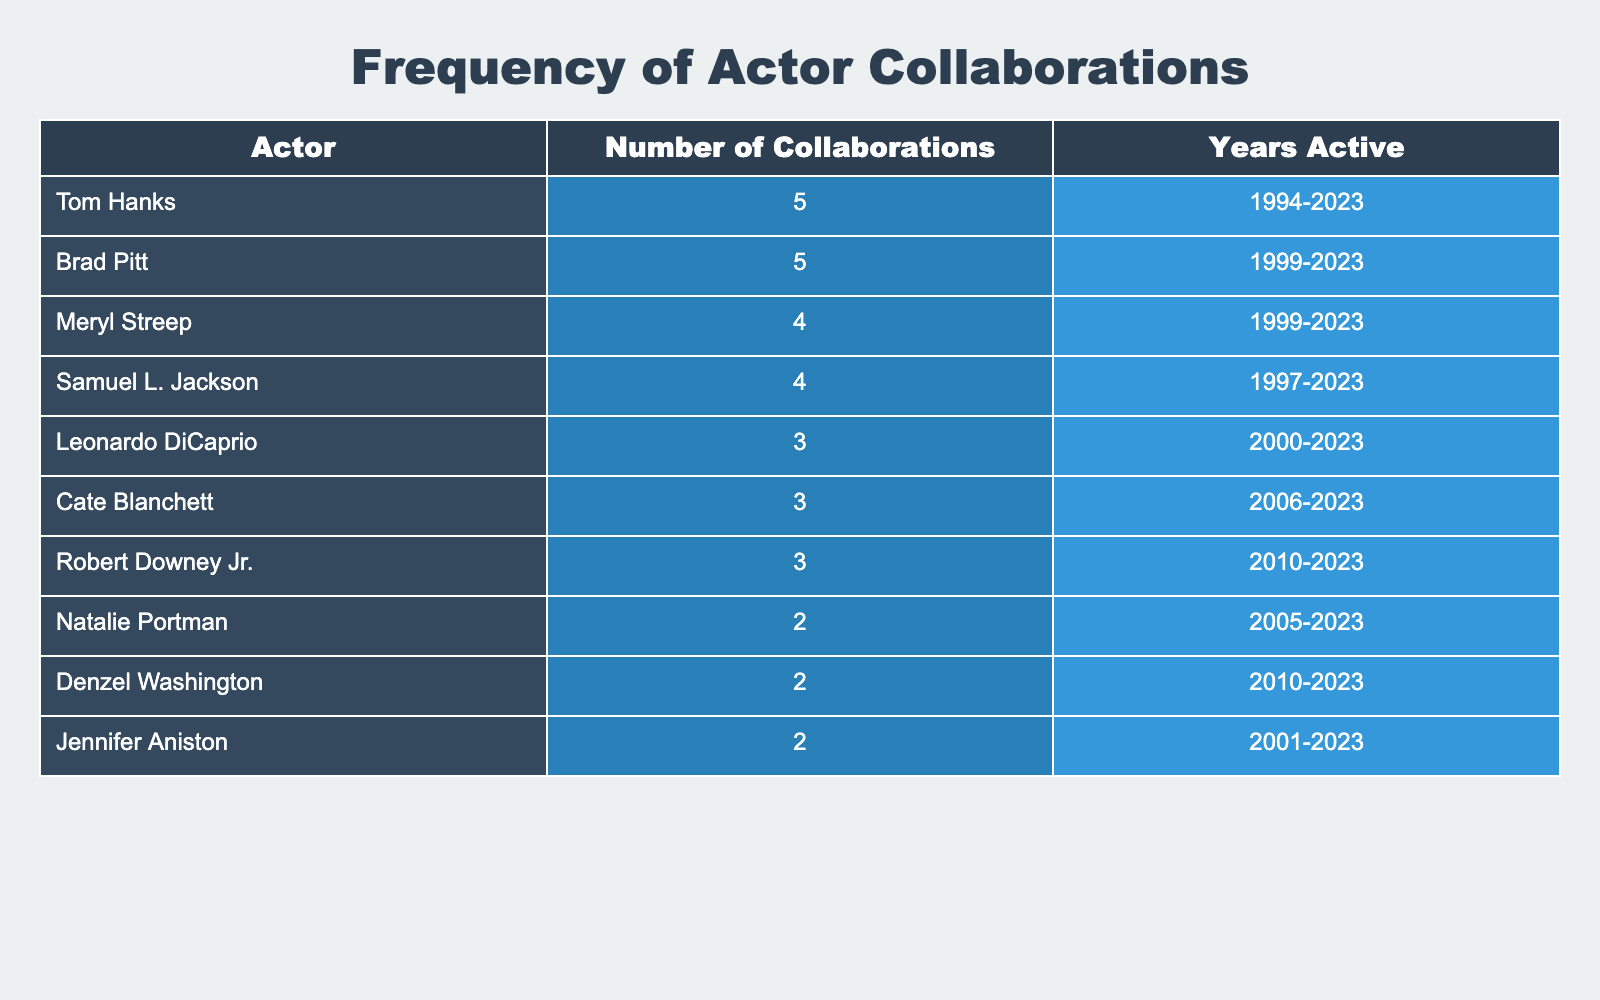What is the actor with the highest number of collaborations? By examining the table, we can see that Tom Hanks and Brad Pitt each have 5 collaborations listed, which is the highest number.
Answer: Tom Hanks and Brad Pitt How many actors have 3 or more collaborations? Upon reviewing the table, we find that there are four actors listed with 3 or more collaborations: Tom Hanks, Brad Pitt, Samuel L. Jackson, and Cate Blanchett.
Answer: 4 Is it true that Natalie Portman has collaborated more than Denzel Washington? Looking at the number of collaborations, Natalie Portman has 2 while Denzel Washington has 2 as well. Since they have the same number, the statement is false.
Answer: No What is the total number of collaborations among actors who are active since 2000 or later? Focusing on actors who have been active since 2000, we see Leonardo DiCaprio (3), Cate Blanchett (3), Robert Downey Jr. (3), Samuel L. Jackson (4), and Brad Pitt (5). Adding these gives us a total of 3 + 3 + 3 + 4 + 5 = 18 collaborations.
Answer: 18 Which actor has the least number of collaborations on this list? By looking at the table, we find that both Natalie Portman, Denzel Washington, and Jennifer Aniston all have the least number, which is 2 collaborations.
Answer: Natalie Portman, Denzel Washington, and Jennifer Aniston How many actors listed have been active since the 1990s? The table shows that the actors active since the 1990s are Tom Hanks, Meryl Streep, Samuel L. Jackson, and Jennifer Aniston. Therefore, there are 4 actors.
Answer: 4 What is the median number of collaborations among these actors? To find the median, we arrange the number of collaborations in ascending order: 2, 2, 2, 3, 3, 3, 4, 4, 5, 5. Since there are 10 values, the median is the average of the 5th and 6th values: (3 + 3) / 2 = 3.
Answer: 3 Is Brad Pitt one of the actors with the highest collaborations? Since Brad Pitt has 5 collaborations, which ties with others for the highest number noted in the table, the statement is true.
Answer: Yes 